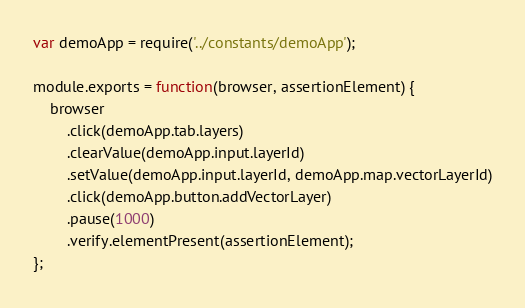Convert code to text. <code><loc_0><loc_0><loc_500><loc_500><_JavaScript_>var demoApp = require('../constants/demoApp');

module.exports = function(browser, assertionElement) {
    browser
        .click(demoApp.tab.layers)
        .clearValue(demoApp.input.layerId)
        .setValue(demoApp.input.layerId, demoApp.map.vectorLayerId)
        .click(demoApp.button.addVectorLayer)
        .pause(1000)
        .verify.elementPresent(assertionElement);
};
</code> 